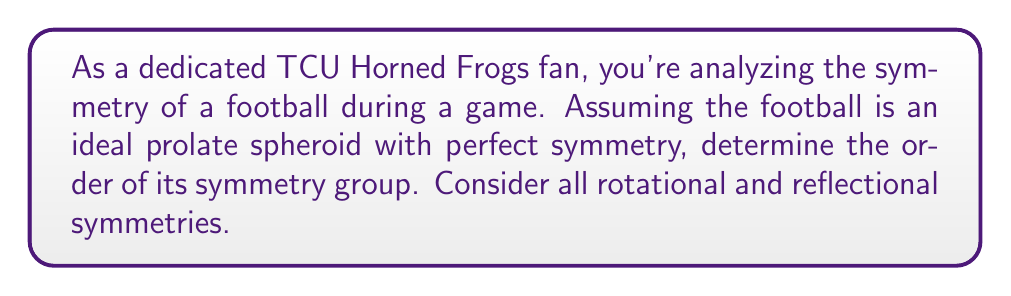Could you help me with this problem? Let's approach this step-by-step:

1) A football, idealized as a prolate spheroid, has the following symmetries:

   a) Rotational symmetry about its long axis (360°)
   b) Two-fold rotational symmetry about any axis perpendicular to the long axis through the center
   c) Reflection symmetry across any plane containing the long axis

2) For the rotational symmetry about the long axis:
   - This is continuous rotational symmetry, represented by the group $SO(2)$, which is infinite.

3) For the two-fold rotational symmetry:
   - There are infinitely many axes perpendicular to the long axis, each providing a 180° rotation.

4) For the reflection symmetry:
   - There are infinitely many planes containing the long axis.

5) The symmetry group of the football is the direct product of $SO(2)$ (rotations about the long axis) and $O(2)$ (rotations and reflections in the plane perpendicular to the long axis).

6) This group is known as $O(2) \times SO(2)$, which is infinite and continuous.

7) In abstract algebra, we say that the order of an infinite group is $\aleph_0$ (aleph-null) for countably infinite groups, or $2^{\aleph_0}$ for uncountably infinite groups.

8) Since $O(2) \times SO(2)$ is uncountably infinite (due to the continuous rotations), its order is $2^{\aleph_0}$.
Answer: The order of the symmetry group of an ideal football is $2^{\aleph_0}$. 